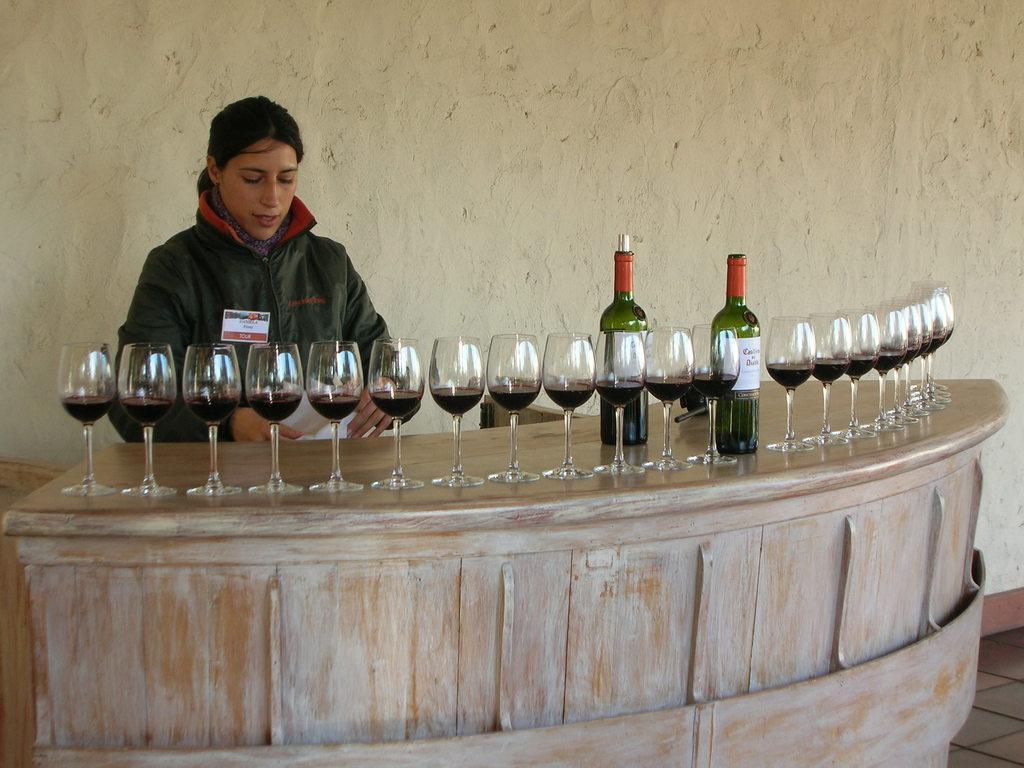In one or two sentences, can you explain what this image depicts? In this image i can see a woman is standing in front of a table. On the table i can see there is a few glasses and two glass bottles on it. 